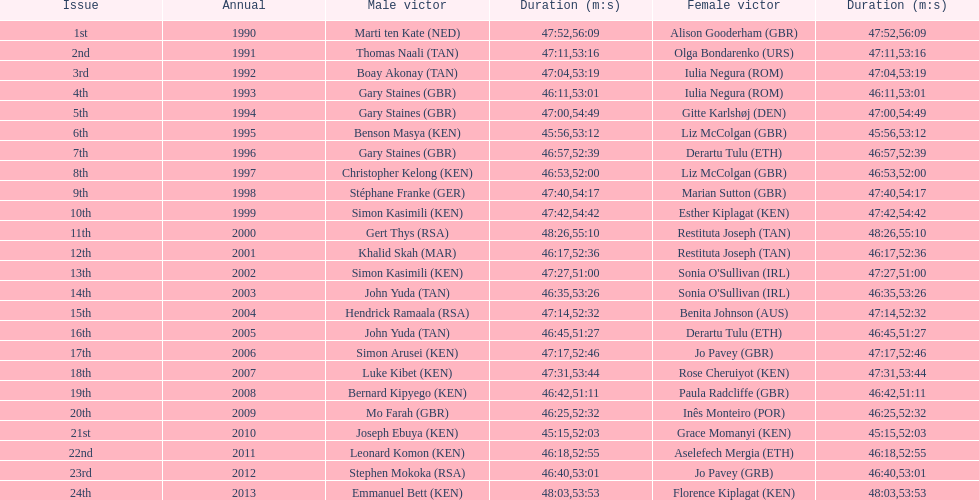Who has the fastest recorded finish for the men's bupa great south run, between 1990 and 2013? Joseph Ebuya (KEN). 